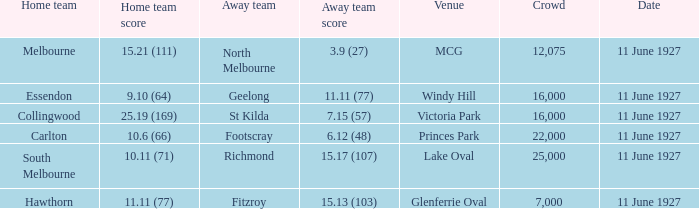What was the score for the home team of Essendon? 9.10 (64). 